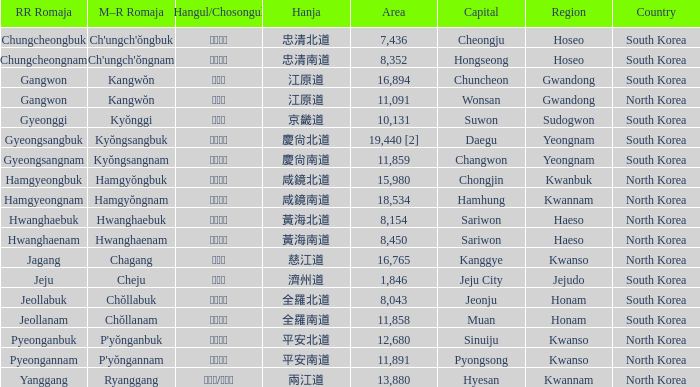Identify the capital that is written as 경상남도 in hangul. Changwon. 